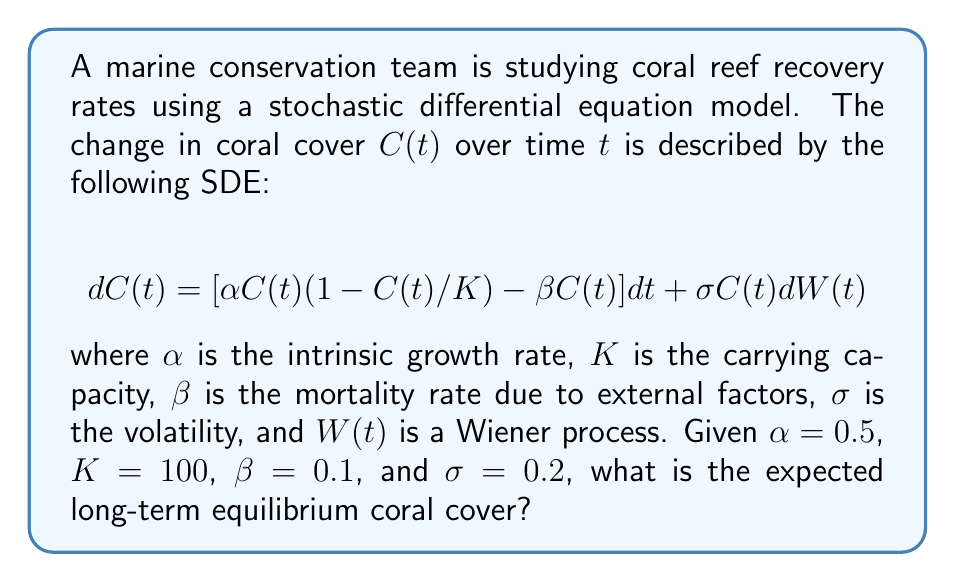What is the answer to this math problem? To find the long-term equilibrium coral cover, we need to follow these steps:

1) In the long-term equilibrium, the deterministic part of the SDE should equal zero:

   $$\alpha C(1-C/K) - \beta C = 0$$

2) Substituting the given values:

   $$0.5C(1-C/100) - 0.1C = 0$$

3) Factoring out C:

   $$C[0.5(1-C/100) - 0.1] = 0$$

4) This equation has two solutions: $C = 0$ or the term in brackets equals zero. Let's solve the latter:

   $$0.5(1-C/100) - 0.1 = 0$$

5) Multiply both sides by 2:

   $$1-C/100 - 0.2 = 0$$

6) Subtract 0.2 from both sides:

   $$0.8-C/100 = 0$$

7) Multiply both sides by 100:

   $$80-C = 0$$

8) Solve for C:

   $$C = 80$$

Therefore, the expected long-term equilibrium coral cover is 80% of the carrying capacity.
Answer: 80 